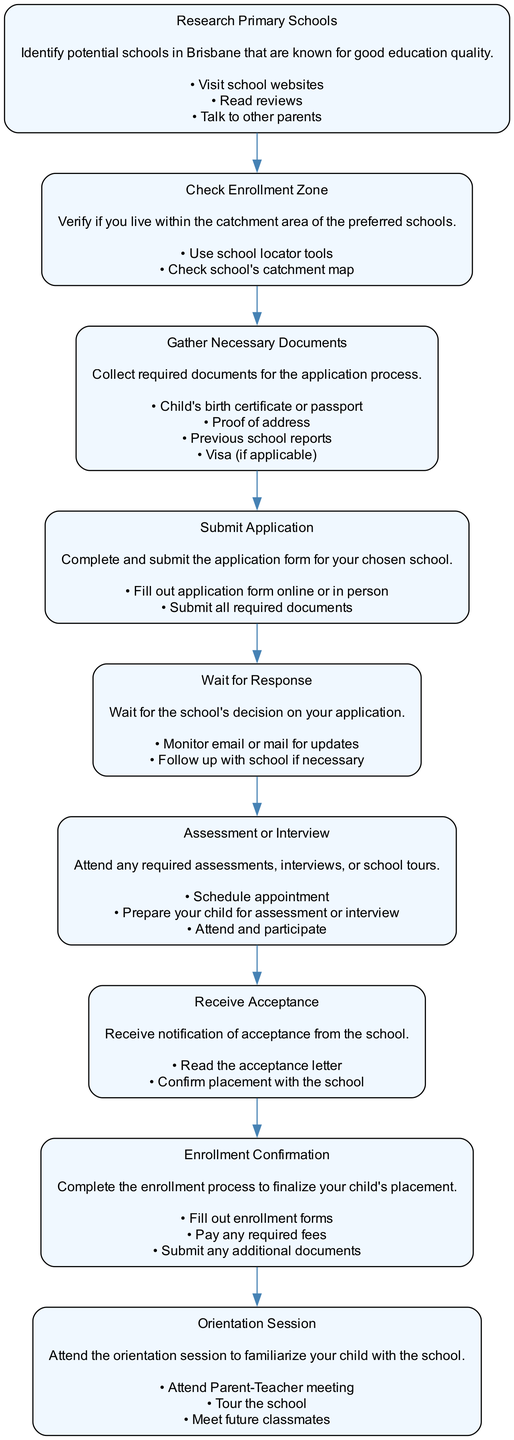What is the first step in the diagram? The first step is labeled as "Research Primary Schools," which is where you begin the enrollment process by identifying potential schools known for good education quality.
Answer: Research Primary Schools How many actions are listed under the "Gather Necessary Documents" step? Under the "Gather Necessary Documents" step, there are four actions listed: child's birth certificate or passport, proof of address, previous school reports, and visa if applicable. Therefore, the total number of actions is four.
Answer: 4 What comes immediately after "Submit Application"? The step that comes immediately after "Submit Application" is "Wait for Response." This means once the application is submitted, the next action is to wait for the school's decision.
Answer: Wait for Response What is the last step in the enrollment process? The last step in the diagram is "Orientation Session," where parents and children attend a session to familiarize themselves with the school environment before starting classes.
Answer: Orientation Session Which two steps require attending something? The two steps that require attending something are "Assessment or Interview," where you attend assessments, interviews, or tours, and "Orientation Session," where you attend a session to familiarize your child with the school.
Answer: Assessment or Interview, Orientation Session What must be done after receiving the acceptance letter? After receiving the acceptance letter, the next action to be taken is to "Confirm placement with the school." This is a crucial step to ensure your child's placement is secured.
Answer: Confirm placement with the school What do you do in the "Check Enrollment Zone" step? In the "Check Enrollment Zone" step, you verify if you live within the catchment area of the preferred schools, utilizing tools such as school locator or the school's catchment map.
Answer: Verify living in catchment area How many steps are there in the entire enrollment process? The entire enrollment process consists of eight steps as listed in the diagram, each leading to the next until the enrollment is finalized.
Answer: 8 What actions are common in both the "Submit Application" and "Enrollment Confirmation" steps? The common actions in both the "Submit Application" and "Enrollment Confirmation" steps include completing forms and submitting required documents, indicating a similarity in the formal requirements at these stages.
Answer: Completing forms, submitting documents 